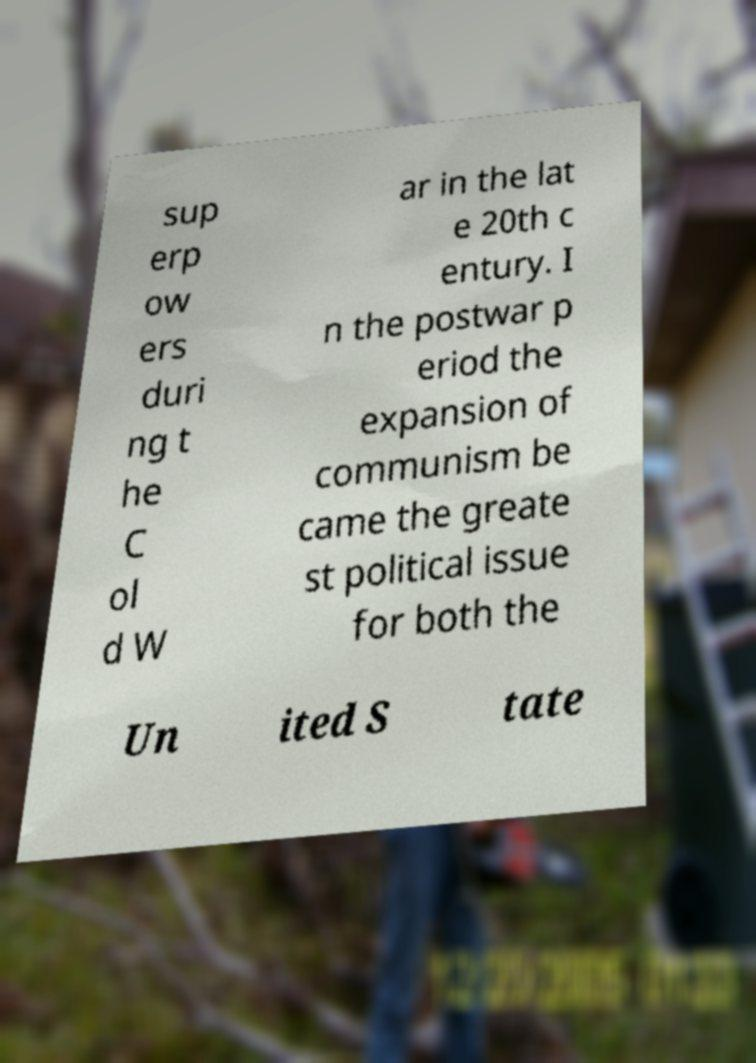Could you assist in decoding the text presented in this image and type it out clearly? sup erp ow ers duri ng t he C ol d W ar in the lat e 20th c entury. I n the postwar p eriod the expansion of communism be came the greate st political issue for both the Un ited S tate 